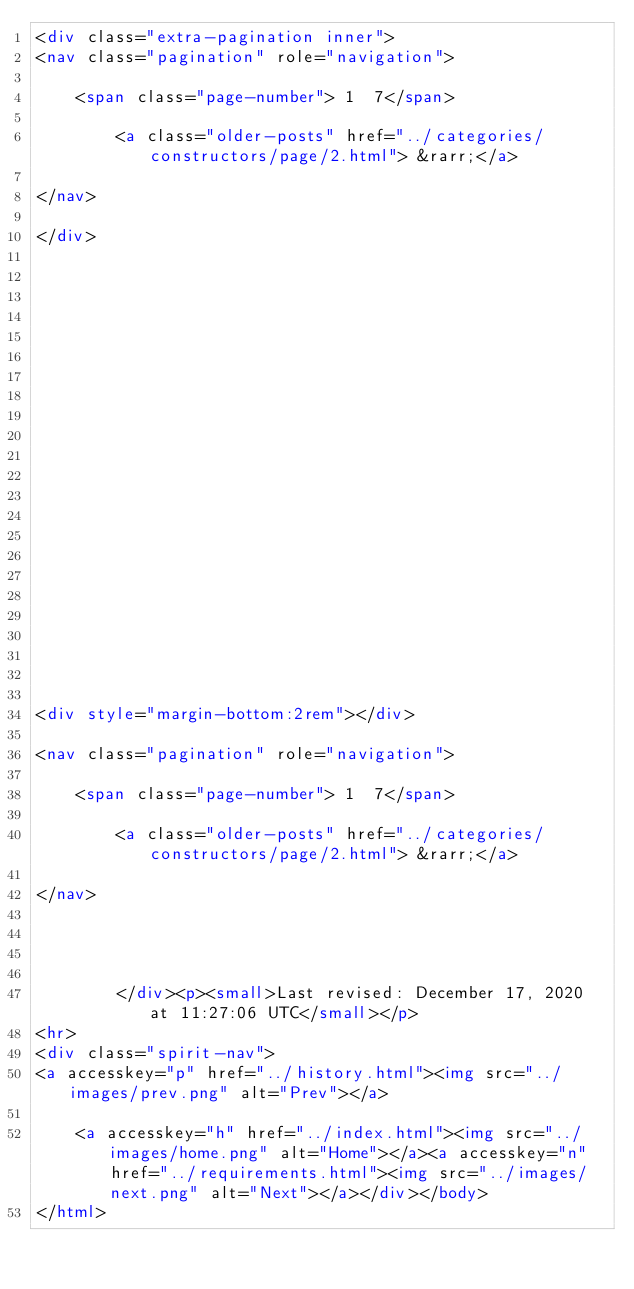Convert code to text. <code><loc_0><loc_0><loc_500><loc_500><_HTML_><div class="extra-pagination inner">
<nav class="pagination" role="navigation">
	
	<span class="page-number"> 1  7</span>
	
	    <a class="older-posts" href="../categories/constructors/page/2.html"> &rarr;</a>
	
</nav>

</div>


   

   

   

   

   

   

   

   

   

   


<div style="margin-bottom:2rem"></div>

<nav class="pagination" role="navigation">
	
	<span class="page-number"> 1  7</span>
	
	    <a class="older-posts" href="../categories/constructors/page/2.html"> &rarr;</a>
	
</nav>




        </div><p><small>Last revised: December 17, 2020 at 11:27:06 UTC</small></p>
<hr>
<div class="spirit-nav">
<a accesskey="p" href="../history.html"><img src="../images/prev.png" alt="Prev"></a>
    
    <a accesskey="h" href="../index.html"><img src="../images/home.png" alt="Home"></a><a accesskey="n" href="../requirements.html"><img src="../images/next.png" alt="Next"></a></div></body>
</html>
</code> 